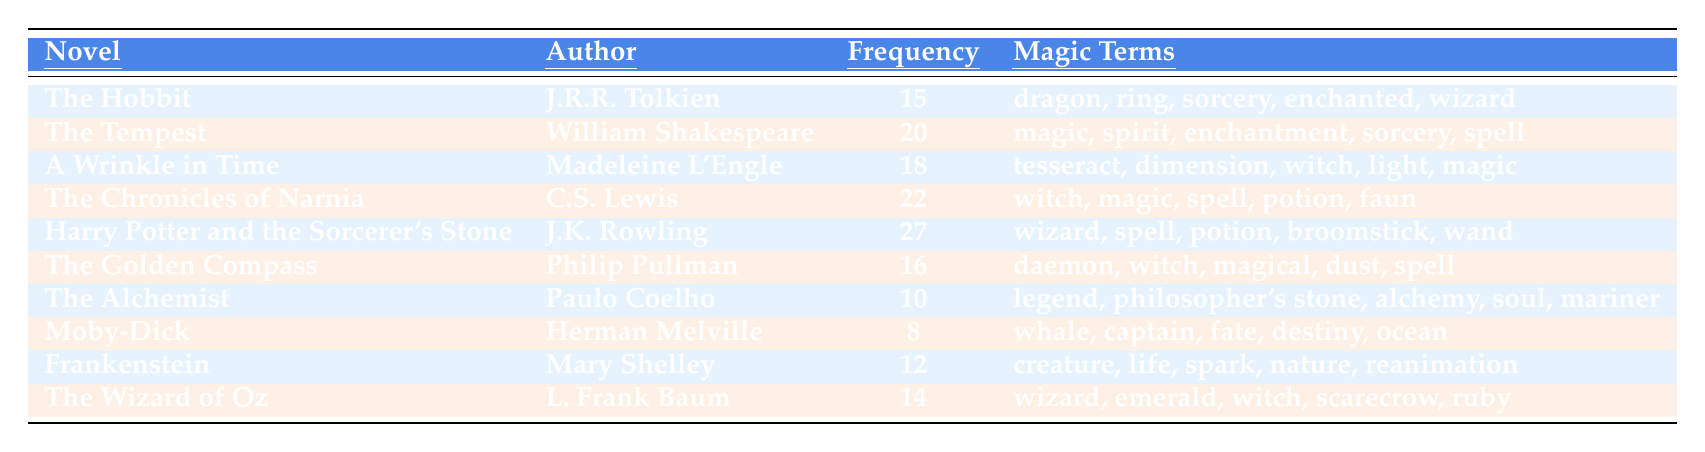What is the novel with the highest frequency of magic-related terminology? By examining the frequency column, we find that "Harry Potter and the Sorcerer's Stone" has the highest value of 27.
Answer: Harry Potter and the Sorcerer's Stone Which author has works that include the terms "potion" and "spell"? Checking the magic terms for each novel, both "Harry Potter and the Sorcerer's Stone" and "The Chronicles of Narnia" include the terms "potion" and "spell".
Answer: J.K. Rowling, C.S. Lewis What is the average frequency of magic-related terminology across all the novels listed? First, we sum the frequencies: (15 + 20 + 18 + 22 + 27 + 16 + 10 + 8 + 12 + 14) = 162. There are 10 novels, so the average is 162 / 10 = 16.2.
Answer: 16.2 Is "Frankenstein" associated with a higher frequency of magic-related terminology than "The Alchemist"? Comparing their frequencies, "Frankenstein" has a frequency of 12, while "The Alchemist" has 10, which means "Frankenstein" is associated with a higher frequency.
Answer: Yes List the magic-related terms used in "The Golden Compass". Referring to the "magicTerms" column for "The Golden Compass", the terms are daemon, witch, magical, dust, and spell.
Answer: daemon, witch, magical, dust, spell What is the difference in frequency of magic-related terminology between "The Tempest" and "Moby-Dick"? The frequency for "The Tempest" is 20 and for "Moby-Dick" is 8. The difference is 20 - 8 = 12.
Answer: 12 Which novels have a frequency of magic-related terminology that is below 15? From the table, "Moby-Dick" (8), "The Alchemist" (10), and "The Wizard of Oz" (14) have frequencies below 15.
Answer: Moby-Dick, The Alchemist, The Wizard of Oz Which author's works contain the term "witch" the most? Checking the novels, "The Chronicles of Narnia" and "The Golden Compass" both include "witch". Each of these novels mentions "witch" once, so no author has it featured more than once in the same work.
Answer: C.S. Lewis, Philip Pullman What would be the outcome if we ranked the novels by frequency and took the top three? The top three ranked by frequency are "Harry Potter and the Sorcerer's Stone" (27), "The Chronicles of Narnia" (22), and "The Tempest" (20).
Answer: Harry Potter and the Sorcerer's Stone, The Chronicles of Narnia, The Tempest What percentage of the total occurrences does "The Hobbit" represent? "The Hobbit" has a frequency of 15. The total frequency is 162. Therefore, the percentage is (15 / 162) * 100 = 9.26%.
Answer: 9.26% 